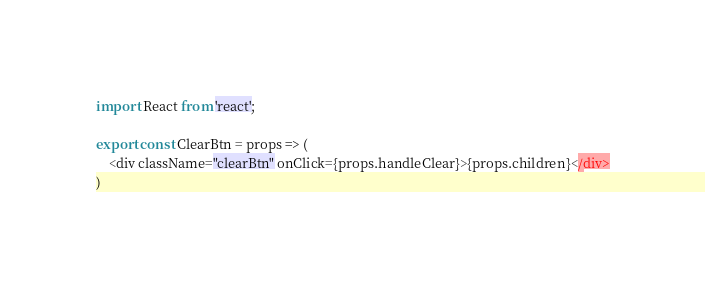Convert code to text. <code><loc_0><loc_0><loc_500><loc_500><_JavaScript_>import React from 'react';

export const ClearBtn = props => (
    <div className="clearBtn" onClick={props.handleClear}>{props.children}</div>
)</code> 